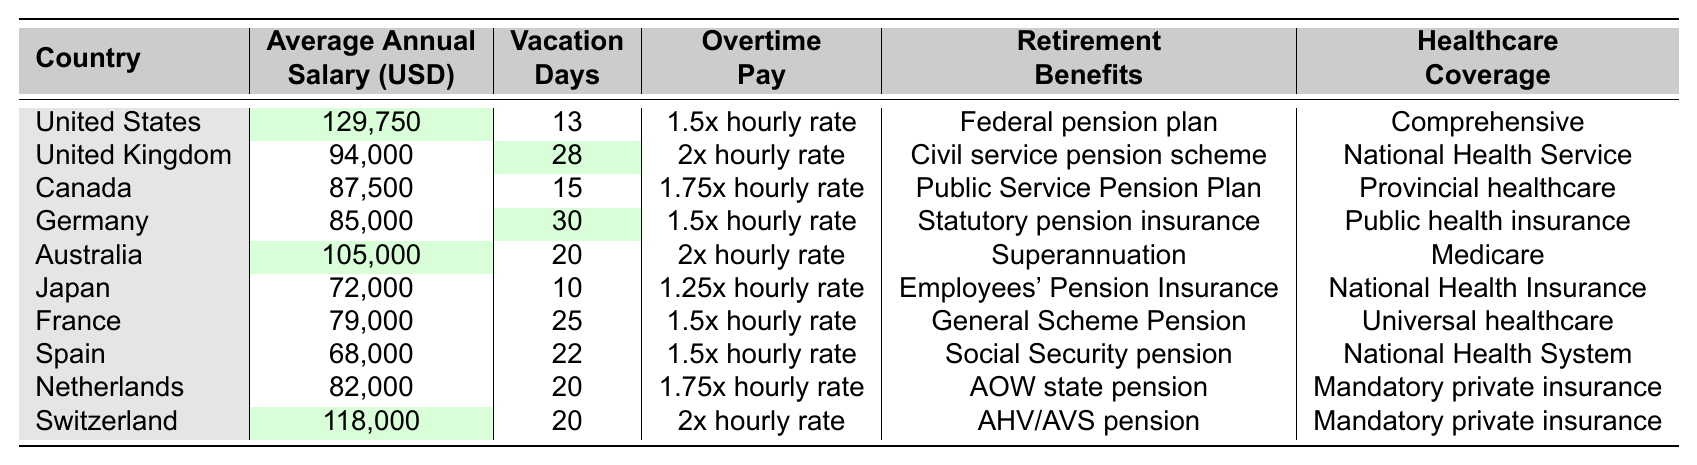What is the average annual salary for air traffic controllers in the United States? The table shows that the average annual salary for air traffic controllers in the United States is 129,750 USD.
Answer: 129,750 USD Which country has the highest number of vacation days for air traffic controllers? The table indicates that the United Kingdom has the highest number of vacation days at 28, compared to other countries.
Answer: United Kingdom How much is the overtime pay for air traffic controllers in Canada? According to the table, the overtime pay for air traffic controllers in Canada is 1.75 times the hourly rate.
Answer: 1.75x hourly rate Are healthcare coverage options mandatory in Switzerland? The table states that Switzerland's healthcare coverage is mandatory private insurance. Therefore, it is mandatory.
Answer: Yes What is the difference in average annual salary between air traffic controllers in the United States and those in Spain? The average salary in the United States is 129,750 USD and in Spain, it is 68,000 USD. The difference is 129,750 - 68,000 = 61,750 USD.
Answer: 61,750 USD Which country provides the lowest average annual salary for air traffic controllers, and what is that salary? Japan has the lowest average annual salary at 72,000 USD.
Answer: Japan, 72,000 USD If we sum the vacation days of air traffic controllers in Germany, Canada, and France, what is the total? The vacation days for Germany (30), Canada (15), and France (25) sum up to 30 + 15 + 25 = 70 days.
Answer: 70 days Which country provides a federal pension plan as a retirement benefit for air traffic controllers? The table shows that the United States provides a federal pension plan for retirement benefits.
Answer: United States What is the average number of vacation days across all countries listed in the table? By adding the vacation days for each country and dividing by the number of countries (13 + 28 + 15 + 30 + 20 + 10 + 25 + 22 + 20 + 20 =  203), the average is 203 / 10 = 20.3 days.
Answer: 20.3 days Is the overtime pay the highest in the United Kingdom compared to other countries? The table states that the United Kingdom offers 2x hourly rate, which is higher than other countries' overtime pay rates.
Answer: Yes 